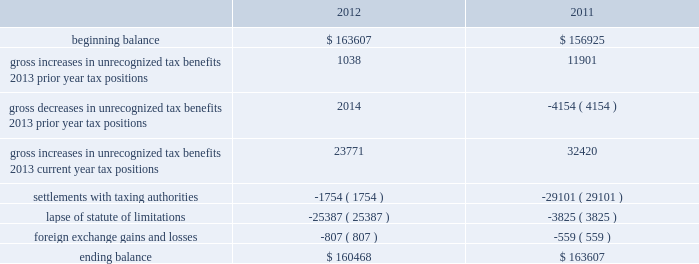Repatriated , the related u.s .
Tax liability may be reduced by any foreign income taxes paid on these earnings .
As of november 30 , 2012 , the cumulative amount of earnings upon which u.s .
Income taxes have not been provided is approximately $ 2.9 billion .
The unrecognized deferred tax liability for these earnings is approximately $ 0.8 billion .
As of november 30 , 2012 , we have u.s .
Net operating loss carryforwards of approximately $ 33.7 million for federal and $ 77.7 million for state .
We also have federal , state and foreign tax credit carryforwards of approximately $ 1.9 million , $ 18.0 million and $ 17.6 million , respectively .
The net operating loss carryforward assets , federal tax credits and foreign tax credits will expire in various years from fiscal 2017 through 2032 .
The state tax credit carryforwards can be carried forward indefinitely .
The net operating loss carryforward assets and certain credits are subject to an annual limitation under internal revenue code section 382 , but are expected to be fully realized .
In addition , we have been tracking certain deferred tax attributes of $ 45.0 million which have not been recorded in the financial statements pursuant to accounting standards related to stock-based compensation .
These amounts are no longer included in our gross or net deferred tax assets .
Pursuant to these standards , the benefit of these deferred tax assets will be recorded to equity if and when they reduce taxes payable .
As of november 30 , 2012 , a valuation allowance of $ 28.2 million has been established for certain deferred tax assets related to the impairment of investments and certain foreign assets .
For fiscal 2012 , the total change in the valuation allowance was $ 23.0 million , of which $ 2.1 million was recorded as a tax benefit through the income statement .
Accounting for uncertainty in income taxes during fiscal 2012 and 2011 , our aggregate changes in our total gross amount of unrecognized tax benefits are summarized as follows ( in thousands ) : .
As of november 30 , 2012 , the combined amount of accrued interest and penalties related to tax positions taken on our tax returns and included in non-current income taxes payable was approximately $ 12.5 million .
We file income tax returns in the u.s .
On a federal basis and in many u.s .
State and foreign jurisdictions .
We are subject to the continual examination of our income tax returns by the irs and other domestic and foreign tax authorities .
Our major tax jurisdictions are the u.s. , ireland and california .
For california , ireland and the u.s. , the earliest fiscal years open for examination are 2005 , 2006 and 2008 , respectively .
We regularly assess the likelihood of outcomes resulting from these examinations to determine the adequacy of our provision for income taxes and have reserved for potential adjustments that may result from the current examinations .
We believe such estimates to be reasonable ; however , there can be no assurance that the final determination of any of these examinations will not have an adverse effect on our operating results and financial position .
In august 2011 , a canadian income tax examination covering our fiscal years 2005 through 2008 was completed .
Our accrued tax and interest related to these years was approximately $ 35 million and was previously reported in long-term income taxes payable .
We reclassified approximately $ 17 million to short-term income taxes payable and decreased deferred tax assets by approximately $ 18 million in conjunction with the aforementioned resolution .
The timing of the resolution of income tax examinations is highly uncertain as are the amounts and timing of tax payments that are part of any audit settlement process .
These events could cause large fluctuations in the balance sheet classification of current and non-current assets and liabilities .
The company believes that before the end of fiscal 2013 , it is reasonably possible table of contents adobe systems incorporated notes to consolidated financial statements ( continued ) .
What is the percentage change in total gross amount of unrecognized tax benefits from 2010 to 2011? 
Computations: ((163607 - 156925) / 156925)
Answer: 0.04258. Repatriated , the related u.s .
Tax liability may be reduced by any foreign income taxes paid on these earnings .
As of november 30 , 2012 , the cumulative amount of earnings upon which u.s .
Income taxes have not been provided is approximately $ 2.9 billion .
The unrecognized deferred tax liability for these earnings is approximately $ 0.8 billion .
As of november 30 , 2012 , we have u.s .
Net operating loss carryforwards of approximately $ 33.7 million for federal and $ 77.7 million for state .
We also have federal , state and foreign tax credit carryforwards of approximately $ 1.9 million , $ 18.0 million and $ 17.6 million , respectively .
The net operating loss carryforward assets , federal tax credits and foreign tax credits will expire in various years from fiscal 2017 through 2032 .
The state tax credit carryforwards can be carried forward indefinitely .
The net operating loss carryforward assets and certain credits are subject to an annual limitation under internal revenue code section 382 , but are expected to be fully realized .
In addition , we have been tracking certain deferred tax attributes of $ 45.0 million which have not been recorded in the financial statements pursuant to accounting standards related to stock-based compensation .
These amounts are no longer included in our gross or net deferred tax assets .
Pursuant to these standards , the benefit of these deferred tax assets will be recorded to equity if and when they reduce taxes payable .
As of november 30 , 2012 , a valuation allowance of $ 28.2 million has been established for certain deferred tax assets related to the impairment of investments and certain foreign assets .
For fiscal 2012 , the total change in the valuation allowance was $ 23.0 million , of which $ 2.1 million was recorded as a tax benefit through the income statement .
Accounting for uncertainty in income taxes during fiscal 2012 and 2011 , our aggregate changes in our total gross amount of unrecognized tax benefits are summarized as follows ( in thousands ) : .
As of november 30 , 2012 , the combined amount of accrued interest and penalties related to tax positions taken on our tax returns and included in non-current income taxes payable was approximately $ 12.5 million .
We file income tax returns in the u.s .
On a federal basis and in many u.s .
State and foreign jurisdictions .
We are subject to the continual examination of our income tax returns by the irs and other domestic and foreign tax authorities .
Our major tax jurisdictions are the u.s. , ireland and california .
For california , ireland and the u.s. , the earliest fiscal years open for examination are 2005 , 2006 and 2008 , respectively .
We regularly assess the likelihood of outcomes resulting from these examinations to determine the adequacy of our provision for income taxes and have reserved for potential adjustments that may result from the current examinations .
We believe such estimates to be reasonable ; however , there can be no assurance that the final determination of any of these examinations will not have an adverse effect on our operating results and financial position .
In august 2011 , a canadian income tax examination covering our fiscal years 2005 through 2008 was completed .
Our accrued tax and interest related to these years was approximately $ 35 million and was previously reported in long-term income taxes payable .
We reclassified approximately $ 17 million to short-term income taxes payable and decreased deferred tax assets by approximately $ 18 million in conjunction with the aforementioned resolution .
The timing of the resolution of income tax examinations is highly uncertain as are the amounts and timing of tax payments that are part of any audit settlement process .
These events could cause large fluctuations in the balance sheet classification of current and non-current assets and liabilities .
The company believes that before the end of fiscal 2013 , it is reasonably possible table of contents adobe systems incorporated notes to consolidated financial statements ( continued ) .
For fiscal 2012 , what percent of the total change in the valuation allowance was recorded as a tax benefit through the income statement?\\n? 
Computations: (2.1 / 23.0)
Answer: 0.0913. 